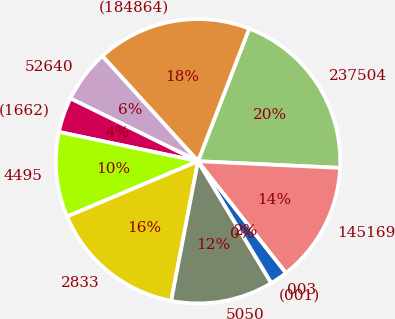<chart> <loc_0><loc_0><loc_500><loc_500><pie_chart><fcel>237504<fcel>(184864)<fcel>52640<fcel>(1662)<fcel>4495<fcel>2833<fcel>5050<fcel>(001)<fcel>003<fcel>145169<nl><fcel>19.89%<fcel>17.61%<fcel>5.97%<fcel>3.98%<fcel>9.66%<fcel>15.62%<fcel>11.65%<fcel>0.0%<fcel>1.99%<fcel>13.64%<nl></chart> 